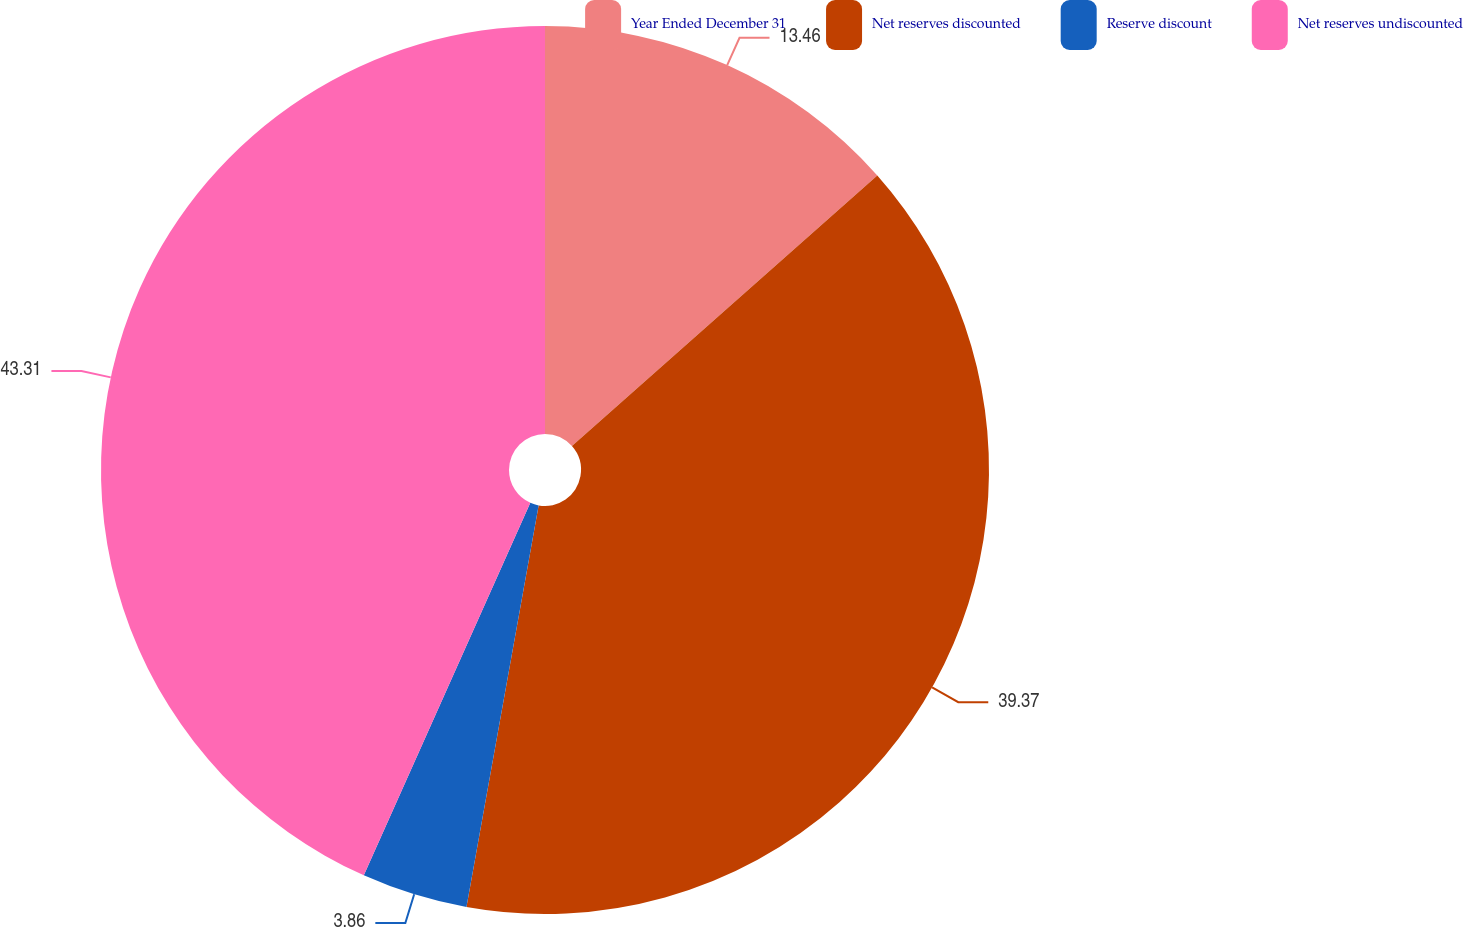Convert chart. <chart><loc_0><loc_0><loc_500><loc_500><pie_chart><fcel>Year Ended December 31<fcel>Net reserves discounted<fcel>Reserve discount<fcel>Net reserves undiscounted<nl><fcel>13.46%<fcel>39.37%<fcel>3.86%<fcel>43.31%<nl></chart> 